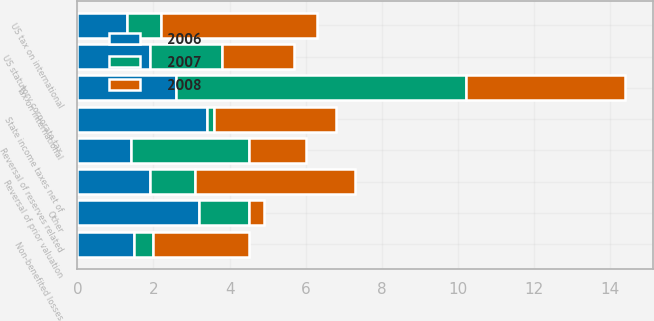<chart> <loc_0><loc_0><loc_500><loc_500><stacked_bar_chart><ecel><fcel>US statutory corporate tax<fcel>Tax on international<fcel>Non-benefited losses<fcel>Reversal of prior valuation<fcel>Reversal of reserves related<fcel>US tax on international<fcel>State income taxes net of<fcel>Other<nl><fcel>2007<fcel>1.9<fcel>7.6<fcel>0.5<fcel>1.2<fcel>3.1<fcel>0.9<fcel>0.2<fcel>1.3<nl><fcel>2008<fcel>1.9<fcel>4.2<fcel>2.5<fcel>4.2<fcel>1.5<fcel>4.1<fcel>3.2<fcel>0.4<nl><fcel>2006<fcel>1.9<fcel>2.6<fcel>1.5<fcel>1.9<fcel>1.4<fcel>1.3<fcel>3.4<fcel>3.2<nl></chart> 